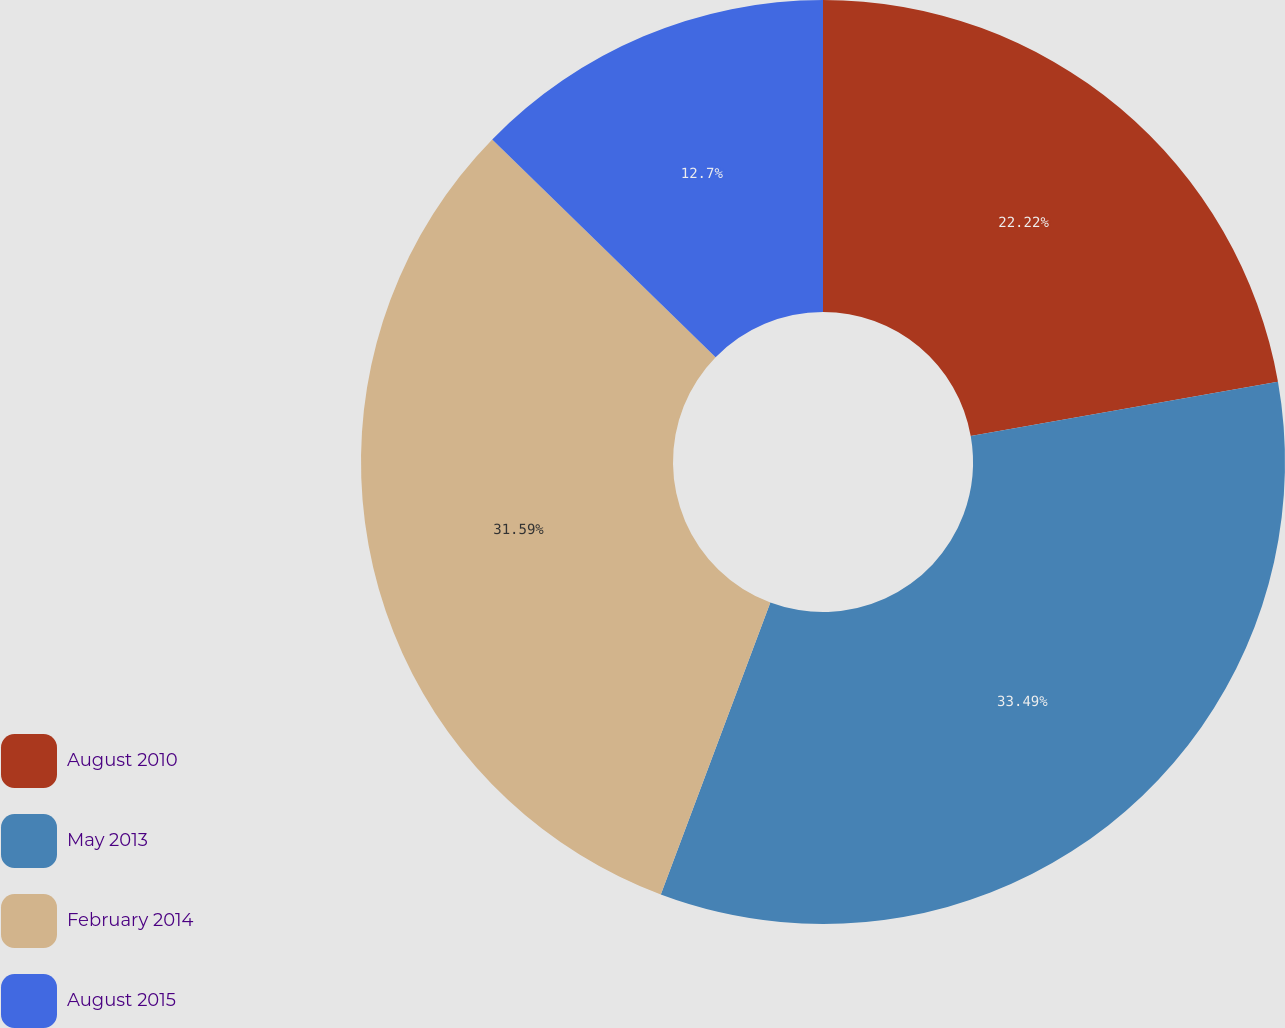Convert chart. <chart><loc_0><loc_0><loc_500><loc_500><pie_chart><fcel>August 2010<fcel>May 2013<fcel>February 2014<fcel>August 2015<nl><fcel>22.22%<fcel>33.49%<fcel>31.59%<fcel>12.7%<nl></chart> 